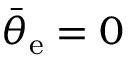Convert formula to latex. <formula><loc_0><loc_0><loc_500><loc_500>\bar { \theta } _ { e } = 0</formula> 